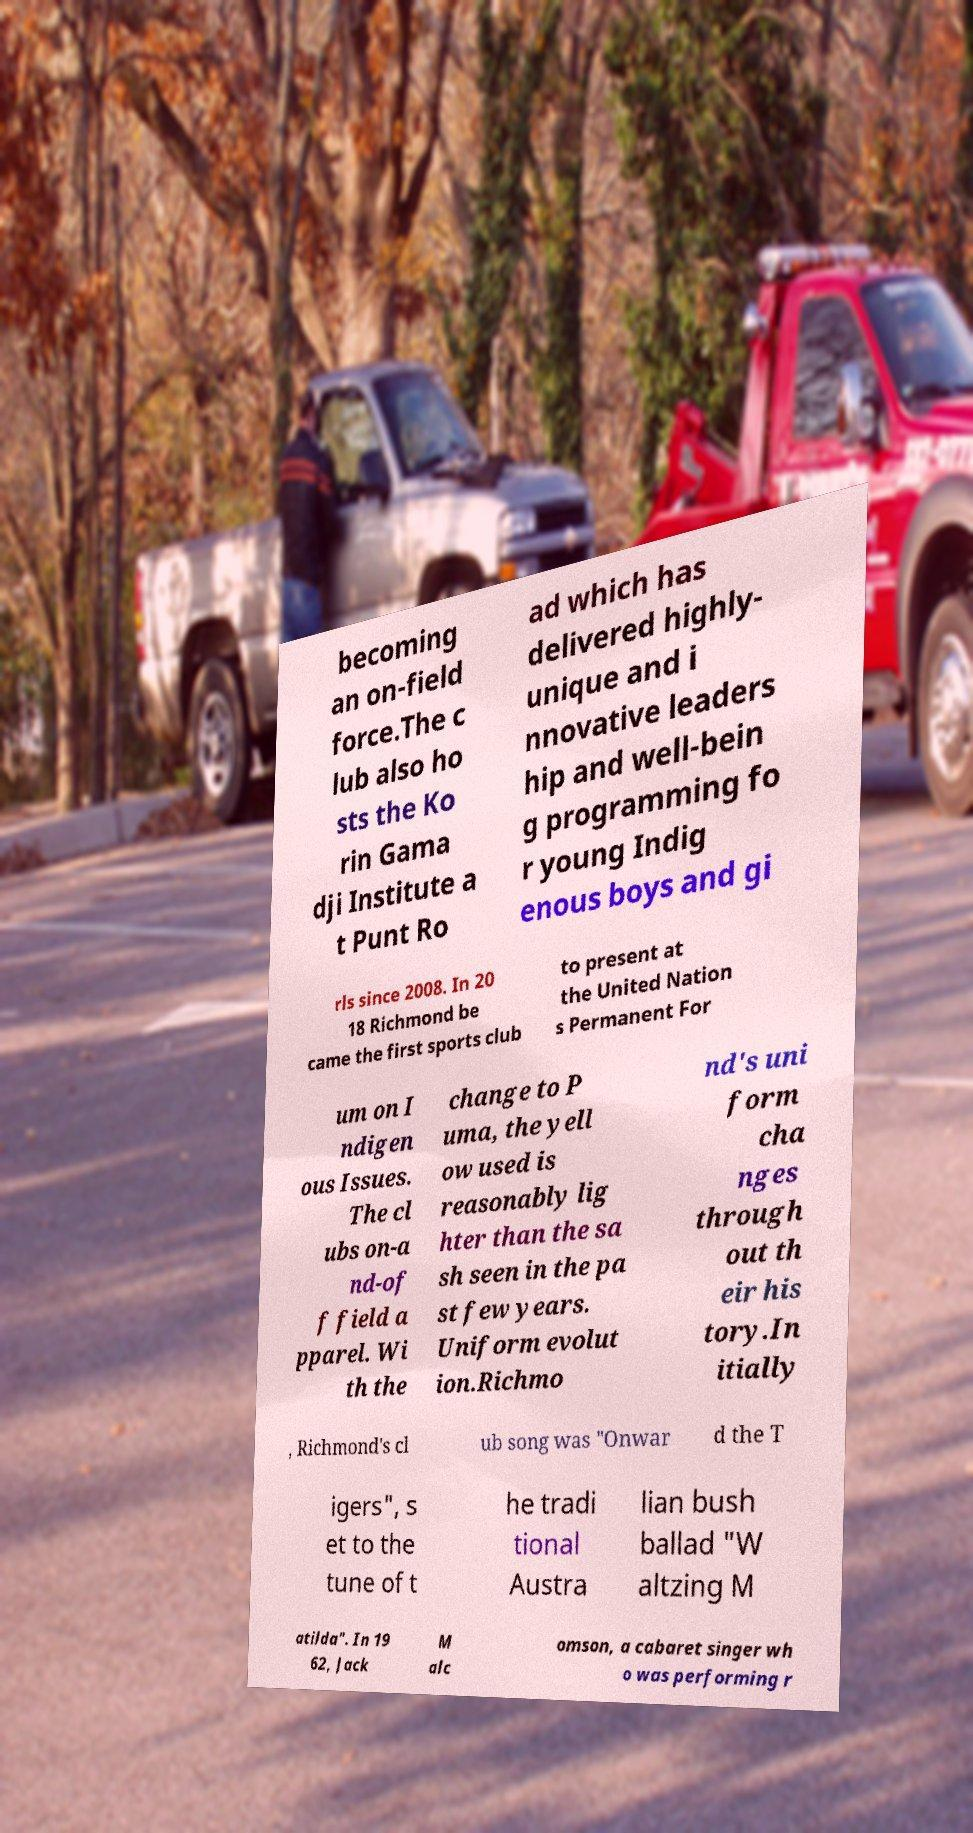There's text embedded in this image that I need extracted. Can you transcribe it verbatim? becoming an on-field force.The c lub also ho sts the Ko rin Gama dji Institute a t Punt Ro ad which has delivered highly- unique and i nnovative leaders hip and well-bein g programming fo r young Indig enous boys and gi rls since 2008. In 20 18 Richmond be came the first sports club to present at the United Nation s Permanent For um on I ndigen ous Issues. The cl ubs on-a nd-of f field a pparel. Wi th the change to P uma, the yell ow used is reasonably lig hter than the sa sh seen in the pa st few years. Uniform evolut ion.Richmo nd's uni form cha nges through out th eir his tory.In itially , Richmond's cl ub song was "Onwar d the T igers", s et to the tune of t he tradi tional Austra lian bush ballad "W altzing M atilda". In 19 62, Jack M alc omson, a cabaret singer wh o was performing r 